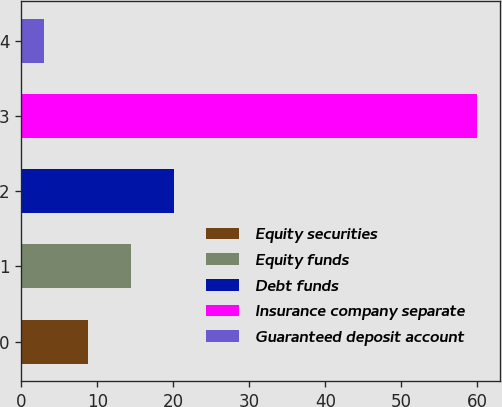Convert chart to OTSL. <chart><loc_0><loc_0><loc_500><loc_500><bar_chart><fcel>Equity securities<fcel>Equity funds<fcel>Debt funds<fcel>Insurance company separate<fcel>Guaranteed deposit account<nl><fcel>8.7<fcel>14.4<fcel>20.1<fcel>60<fcel>3<nl></chart> 